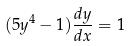<formula> <loc_0><loc_0><loc_500><loc_500>( 5 y ^ { 4 } - 1 ) \frac { d y } { d x } = 1</formula> 